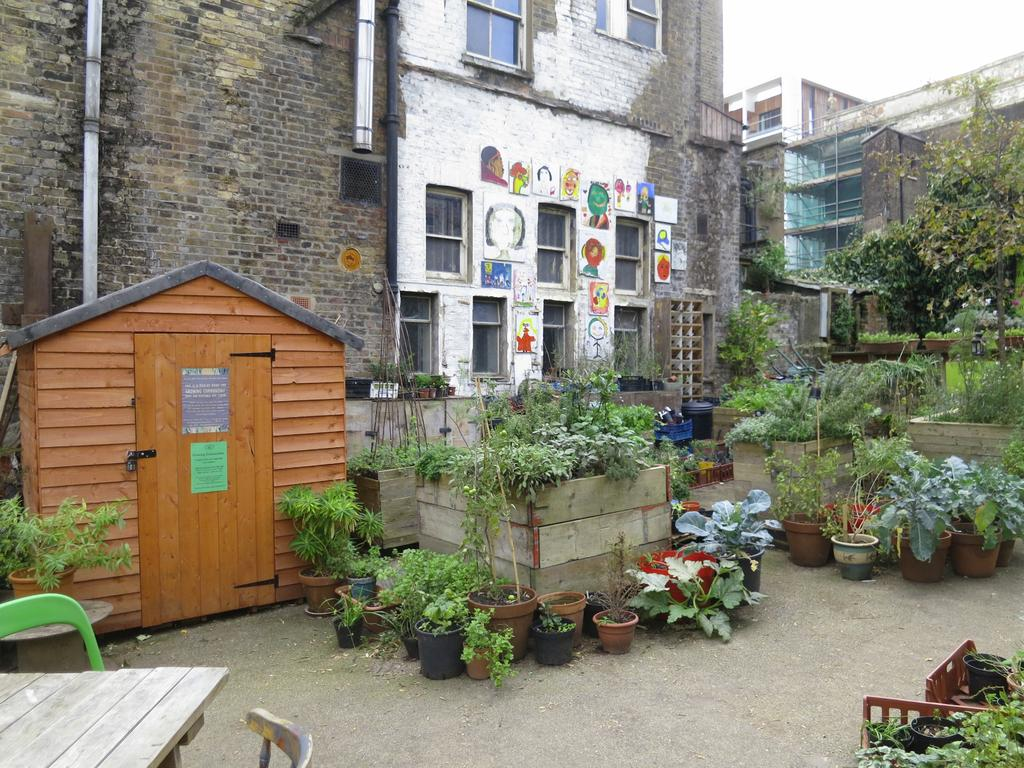What type of living organisms can be seen in the image? Plants can be seen in the image. What type of furniture is present in the image? There are chairs in the image. What type of surface is present in the image for placing objects? There is a table in the image. What type of structure is present in the image that is smaller than a house? There is a shack in the image. What type of structures are present in the image that are larger than a shack? There are buildings in the image. What type of match can be seen being used to create a paste in the image? There is no match or paste present in the image. What type of pleasure can be seen being experienced by the plants in the image? Plants do not experience pleasure, and there are no people or animals present in the image to experience pleasure. 